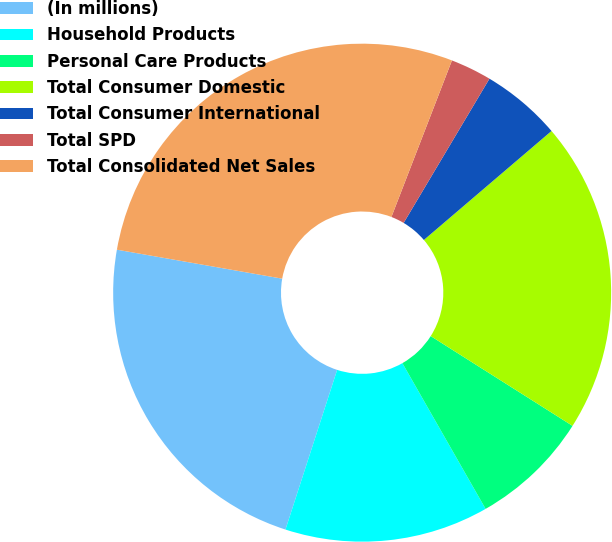Convert chart. <chart><loc_0><loc_0><loc_500><loc_500><pie_chart><fcel>(In millions)<fcel>Household Products<fcel>Personal Care Products<fcel>Total Consumer Domestic<fcel>Total Consumer International<fcel>Total SPD<fcel>Total Consolidated Net Sales<nl><fcel>22.78%<fcel>13.24%<fcel>7.76%<fcel>20.23%<fcel>5.21%<fcel>2.67%<fcel>28.11%<nl></chart> 